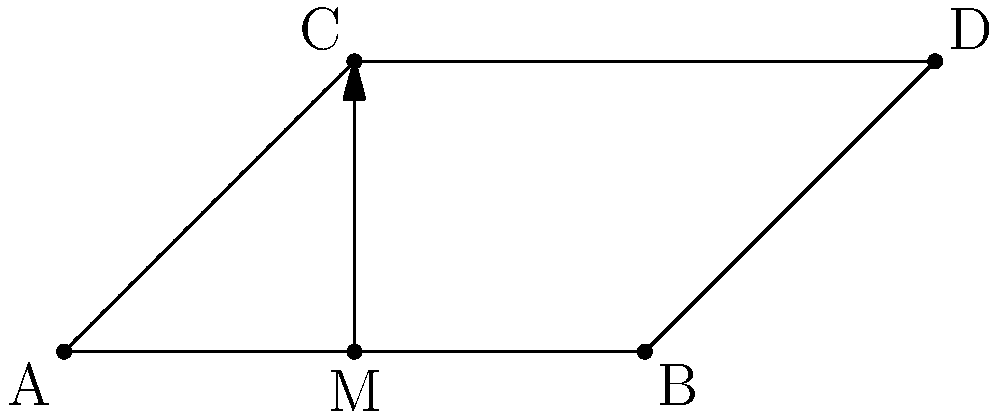In the passing pattern diagram above, players A, B, C, and D form a quadrilateral. If M is the midpoint of AB, which line represents the axis of reflective symmetry for this passing pattern? To determine the axis of reflective symmetry, we need to follow these steps:

1. Identify the shape: The players form a quadrilateral ABCD.

2. Analyze the properties:
   - AB is parallel to CD (horizontal lines)
   - AC and BD are not parallel (diagonal lines)
   - M is the midpoint of AB

3. Consider potential symmetry axes:
   - A vertical line through M could be a symmetry axis
   - The diagonals AC or BD could be symmetry axes

4. Check for reflective symmetry:
   - If we reflect point A across the line M-C, it maps onto point B
   - If we reflect point C across the line M-C, it maps onto point D

5. Confirm the symmetry:
   - The line M-C divides the quadrilateral into two equal halves
   - Each half is a mirror image of the other when reflected across M-C

Therefore, the line from M to C (indicated by the arrow in the diagram) represents the axis of reflective symmetry for this passing pattern.
Answer: M-C 